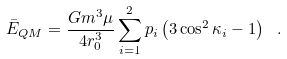Convert formula to latex. <formula><loc_0><loc_0><loc_500><loc_500>\bar { E } _ { Q M } = \frac { G m ^ { 3 } \mu } { 4 r _ { 0 } ^ { 3 } } \sum _ { i = 1 } ^ { 2 } p _ { i } \left ( 3 \cos ^ { 2 } \kappa _ { i } - 1 \right ) \ .</formula> 